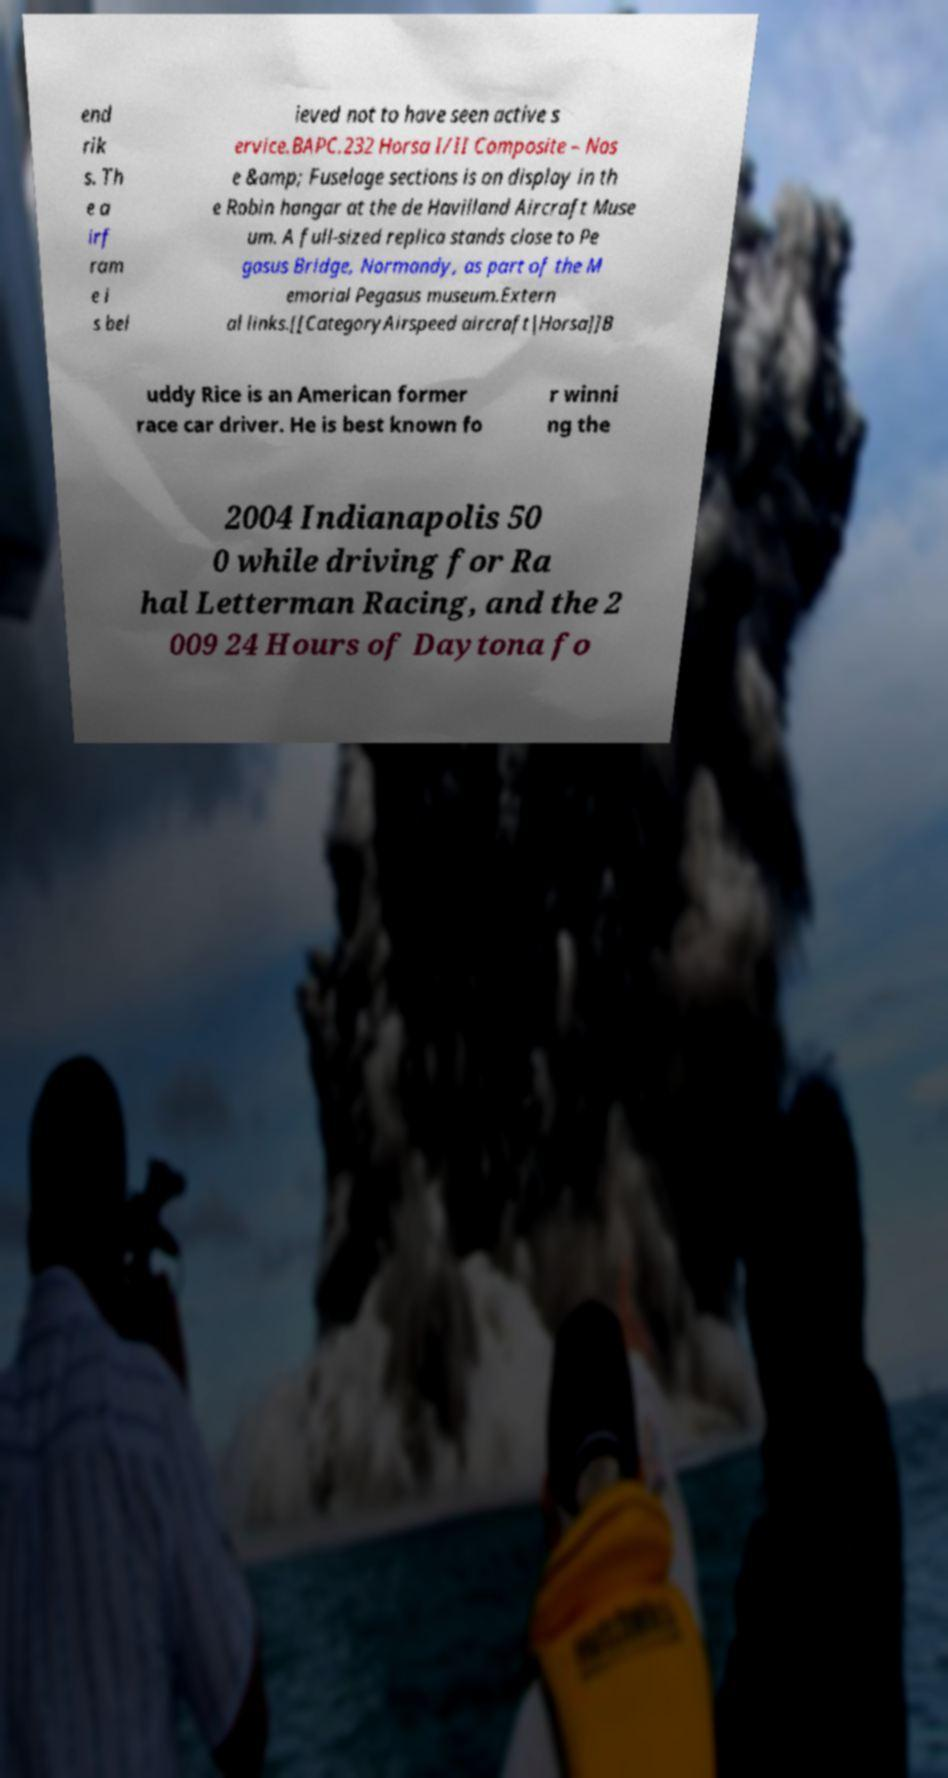Could you assist in decoding the text presented in this image and type it out clearly? end rik s. Th e a irf ram e i s bel ieved not to have seen active s ervice.BAPC.232 Horsa I/II Composite – Nos e &amp; Fuselage sections is on display in th e Robin hangar at the de Havilland Aircraft Muse um. A full-sized replica stands close to Pe gasus Bridge, Normandy, as part of the M emorial Pegasus museum.Extern al links.[[CategoryAirspeed aircraft|Horsa]]B uddy Rice is an American former race car driver. He is best known fo r winni ng the 2004 Indianapolis 50 0 while driving for Ra hal Letterman Racing, and the 2 009 24 Hours of Daytona fo 